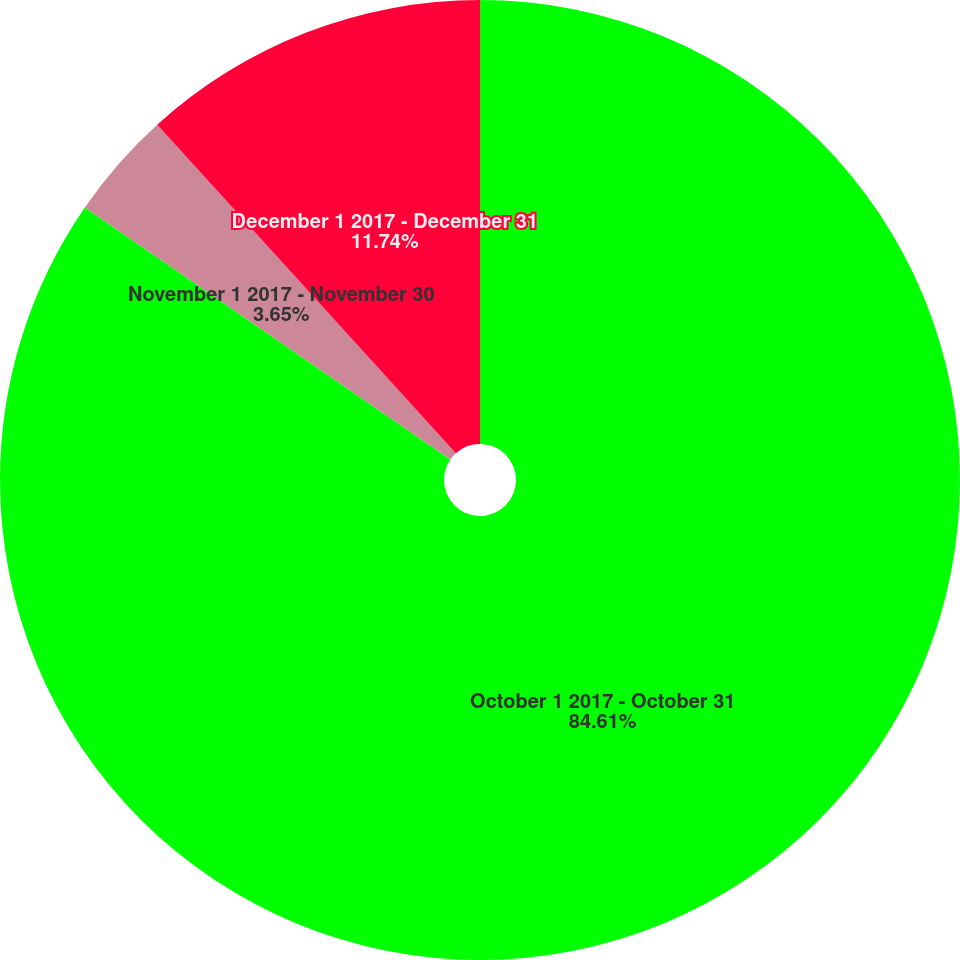Convert chart. <chart><loc_0><loc_0><loc_500><loc_500><pie_chart><fcel>October 1 2017 - October 31<fcel>November 1 2017 - November 30<fcel>December 1 2017 - December 31<nl><fcel>84.61%<fcel>3.65%<fcel>11.74%<nl></chart> 